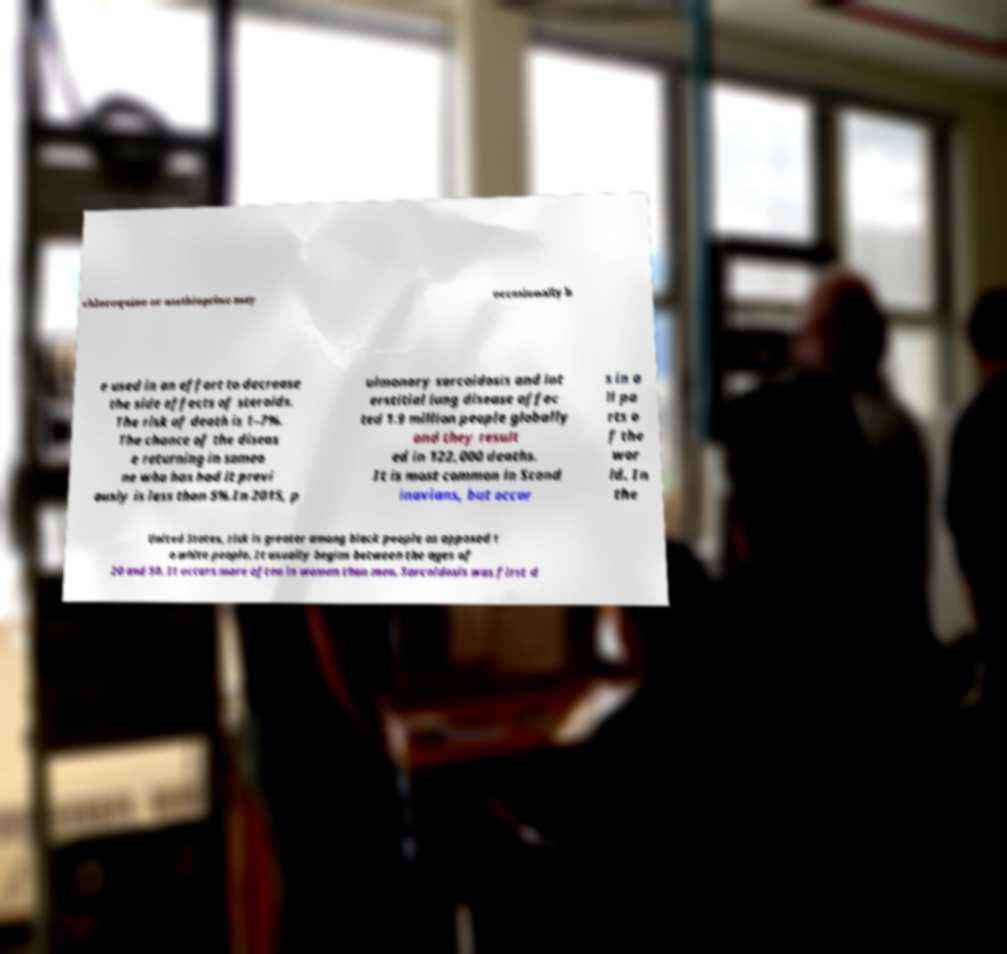For documentation purposes, I need the text within this image transcribed. Could you provide that? chloroquine or azathioprine may occasionally b e used in an effort to decrease the side effects of steroids. The risk of death is 1–7%. The chance of the diseas e returning in someo ne who has had it previ ously is less than 5%.In 2015, p ulmonary sarcoidosis and int erstitial lung disease affec ted 1.9 million people globally and they result ed in 122,000 deaths. It is most common in Scand inavians, but occur s in a ll pa rts o f the wor ld. In the United States, risk is greater among black people as opposed t o white people. It usually begins between the ages of 20 and 50. It occurs more often in women than men. Sarcoidosis was first d 